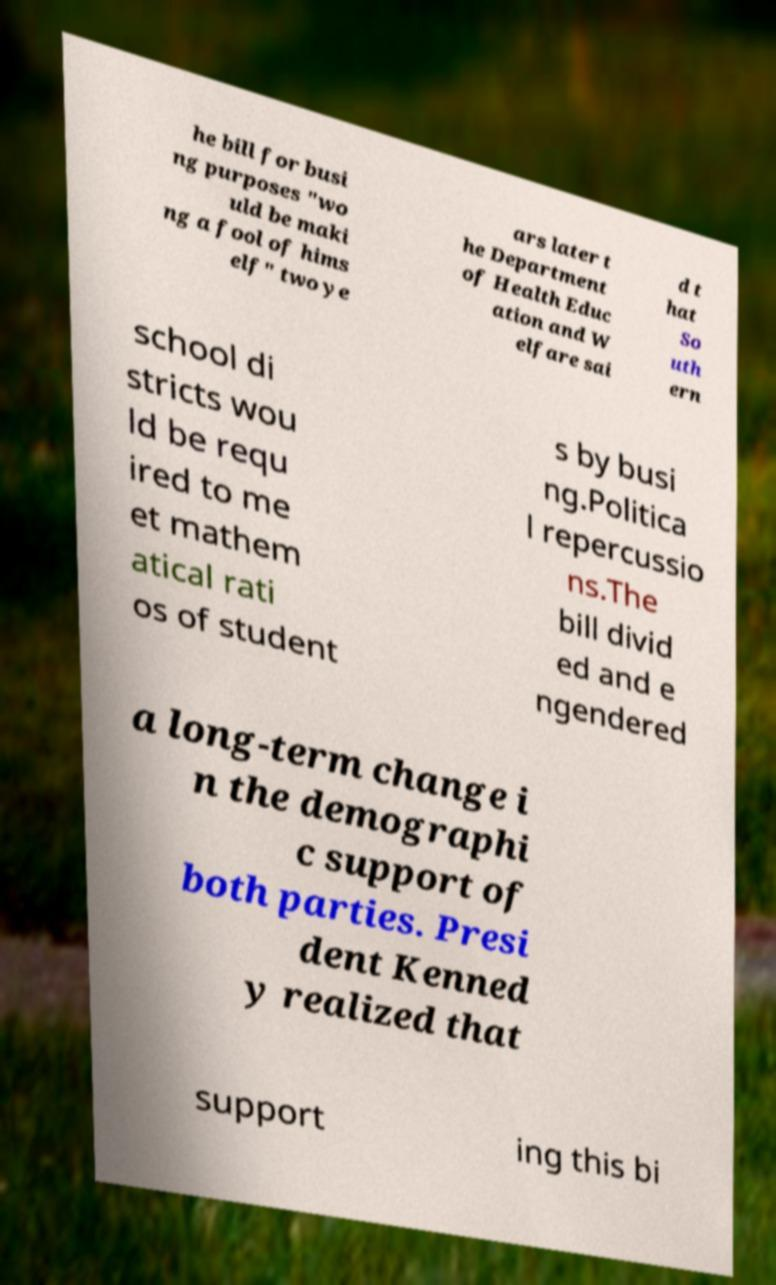Please identify and transcribe the text found in this image. he bill for busi ng purposes "wo uld be maki ng a fool of hims elf" two ye ars later t he Department of Health Educ ation and W elfare sai d t hat So uth ern school di stricts wou ld be requ ired to me et mathem atical rati os of student s by busi ng.Politica l repercussio ns.The bill divid ed and e ngendered a long-term change i n the demographi c support of both parties. Presi dent Kenned y realized that support ing this bi 